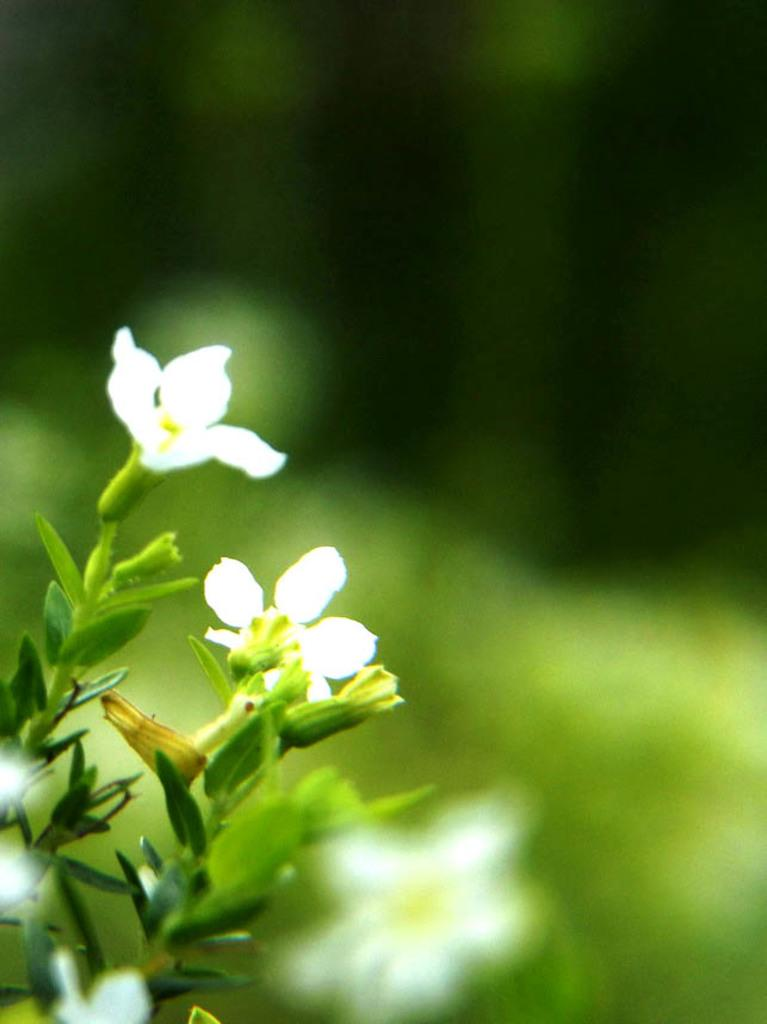What type of plant is on the left side of the image? There is a plant with flowers on the left side of the image. What color are the flowers on the plant? The flowers are white in color. What can be seen in the background of the image? There is a green background in the image. What day of the week is the doctor visiting the patient in the image? There is no doctor or patient present in the image, so it is not possible to determine the day of the week. 